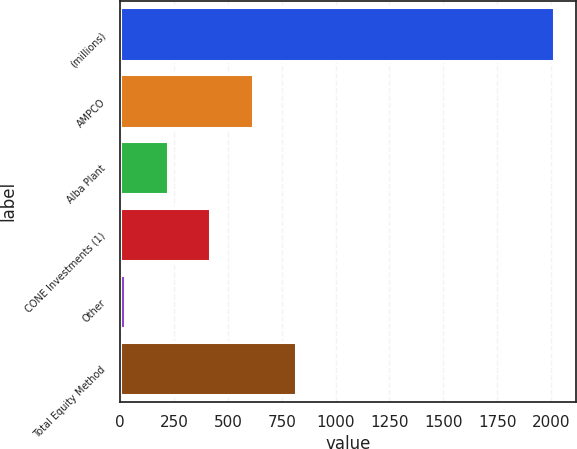Convert chart to OTSL. <chart><loc_0><loc_0><loc_500><loc_500><bar_chart><fcel>(millions)<fcel>AMPCO<fcel>Alba Plant<fcel>CONE Investments (1)<fcel>Other<fcel>Total Equity Method<nl><fcel>2014<fcel>618.2<fcel>219.4<fcel>418.8<fcel>20<fcel>817.6<nl></chart> 